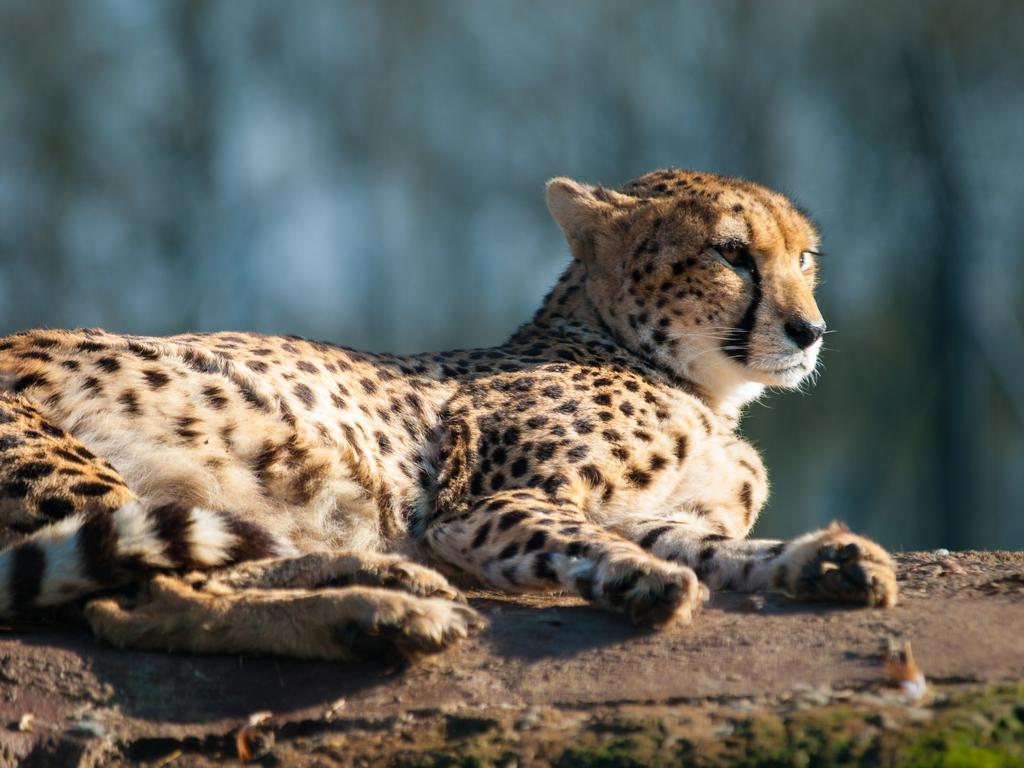What animal is the main subject of the image? There is a cheetah in the image. What is the cheetah doing in the image? The cheetah is lying on the ground. Can you describe the background of the image? The background of the image is blurred. What flavor of ice cream is the cheetah holding in the image? There is no ice cream present in the image, and the cheetah is not holding anything. 